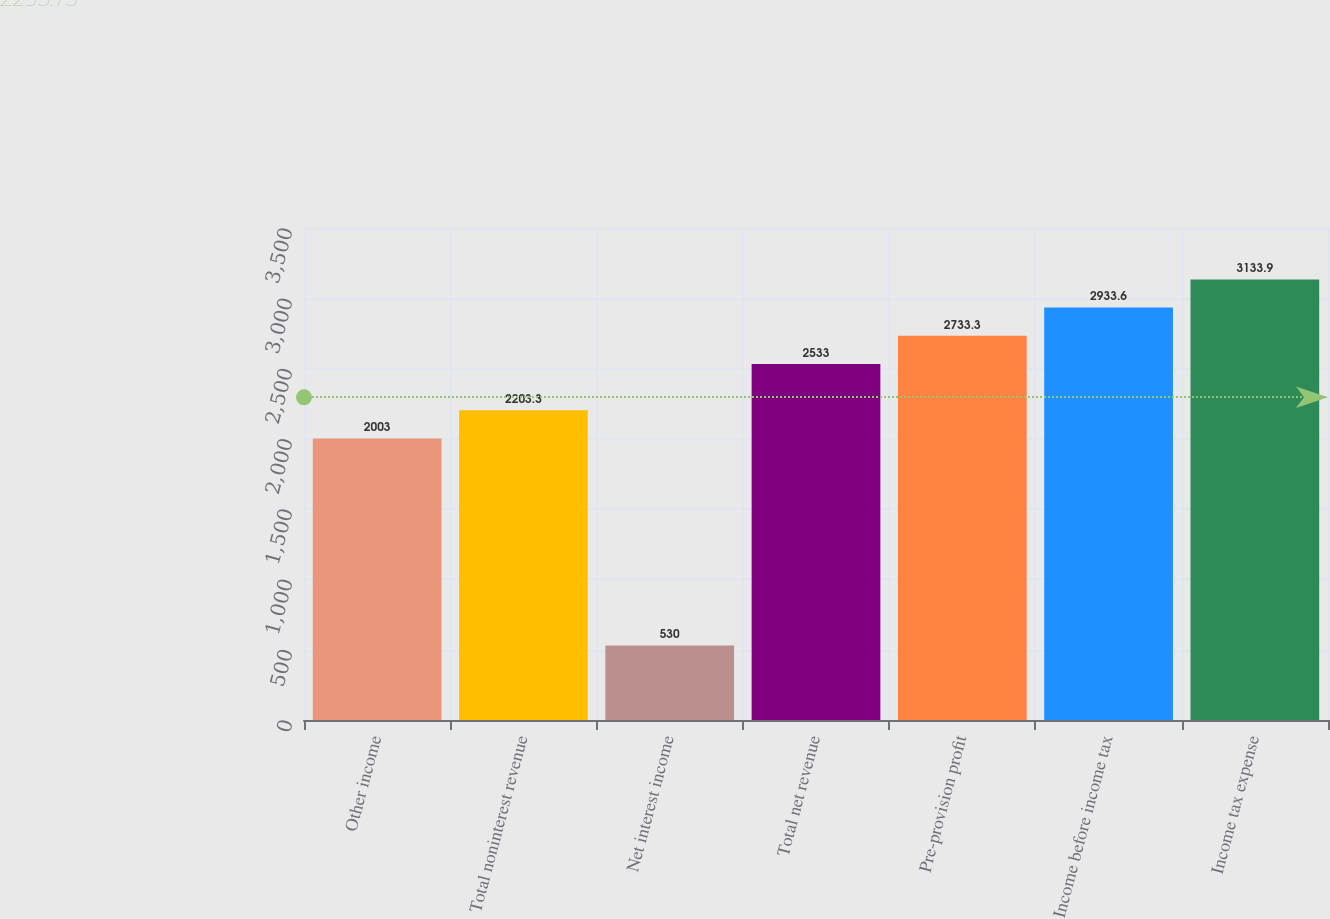Convert chart to OTSL. <chart><loc_0><loc_0><loc_500><loc_500><bar_chart><fcel>Other income<fcel>Total noninterest revenue<fcel>Net interest income<fcel>Total net revenue<fcel>Pre-provision profit<fcel>Income before income tax<fcel>Income tax expense<nl><fcel>2003<fcel>2203.3<fcel>530<fcel>2533<fcel>2733.3<fcel>2933.6<fcel>3133.9<nl></chart> 